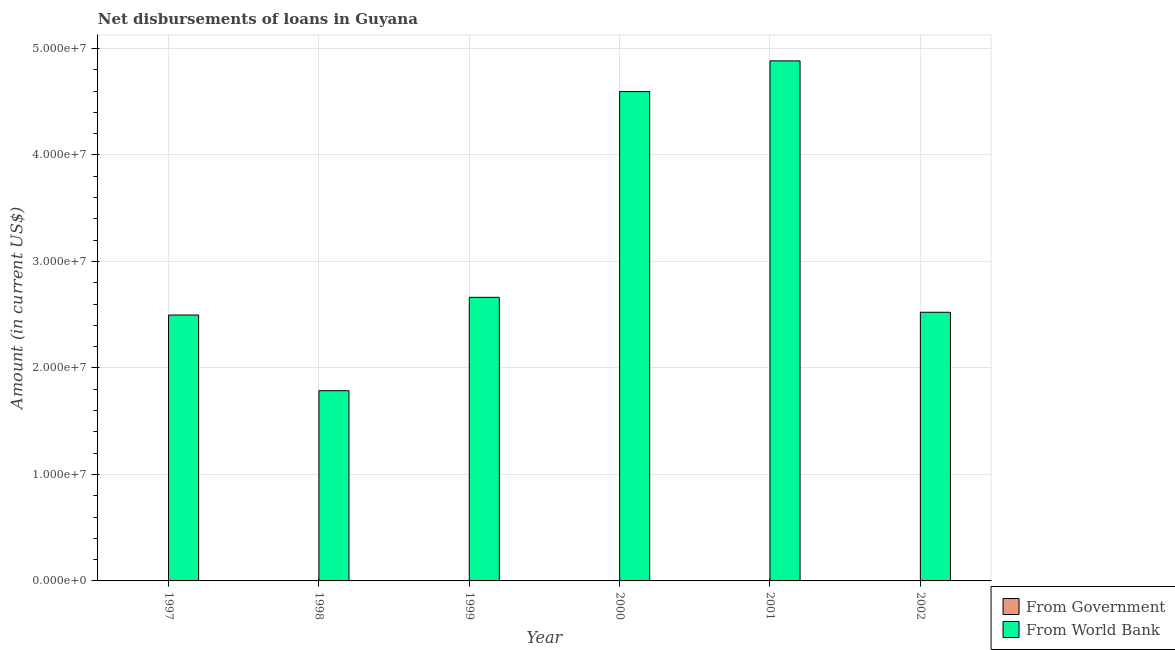How many different coloured bars are there?
Give a very brief answer. 1. Are the number of bars on each tick of the X-axis equal?
Provide a short and direct response. Yes. How many bars are there on the 3rd tick from the right?
Offer a very short reply. 1. What is the label of the 4th group of bars from the left?
Provide a short and direct response. 2000. In how many cases, is the number of bars for a given year not equal to the number of legend labels?
Offer a terse response. 6. Across all years, what is the maximum net disbursements of loan from world bank?
Make the answer very short. 4.88e+07. What is the total net disbursements of loan from world bank in the graph?
Provide a short and direct response. 1.89e+08. What is the difference between the net disbursements of loan from world bank in 1998 and that in 2000?
Your answer should be very brief. -2.81e+07. What is the ratio of the net disbursements of loan from world bank in 1997 to that in 1998?
Ensure brevity in your answer.  1.4. What is the difference between the highest and the second highest net disbursements of loan from world bank?
Provide a short and direct response. 2.88e+06. What is the difference between the highest and the lowest net disbursements of loan from world bank?
Your response must be concise. 3.10e+07. How many bars are there?
Give a very brief answer. 6. How many years are there in the graph?
Offer a terse response. 6. What is the difference between two consecutive major ticks on the Y-axis?
Make the answer very short. 1.00e+07. Are the values on the major ticks of Y-axis written in scientific E-notation?
Your response must be concise. Yes. Where does the legend appear in the graph?
Provide a succinct answer. Bottom right. What is the title of the graph?
Give a very brief answer. Net disbursements of loans in Guyana. What is the label or title of the X-axis?
Offer a very short reply. Year. What is the label or title of the Y-axis?
Your answer should be very brief. Amount (in current US$). What is the Amount (in current US$) of From World Bank in 1997?
Your answer should be very brief. 2.50e+07. What is the Amount (in current US$) in From World Bank in 1998?
Keep it short and to the point. 1.79e+07. What is the Amount (in current US$) of From World Bank in 1999?
Make the answer very short. 2.66e+07. What is the Amount (in current US$) in From Government in 2000?
Give a very brief answer. 0. What is the Amount (in current US$) in From World Bank in 2000?
Offer a very short reply. 4.60e+07. What is the Amount (in current US$) of From World Bank in 2001?
Ensure brevity in your answer.  4.88e+07. What is the Amount (in current US$) in From World Bank in 2002?
Offer a very short reply. 2.52e+07. Across all years, what is the maximum Amount (in current US$) in From World Bank?
Your response must be concise. 4.88e+07. Across all years, what is the minimum Amount (in current US$) in From World Bank?
Your answer should be compact. 1.79e+07. What is the total Amount (in current US$) in From Government in the graph?
Give a very brief answer. 0. What is the total Amount (in current US$) in From World Bank in the graph?
Your response must be concise. 1.89e+08. What is the difference between the Amount (in current US$) of From World Bank in 1997 and that in 1998?
Provide a succinct answer. 7.11e+06. What is the difference between the Amount (in current US$) of From World Bank in 1997 and that in 1999?
Your answer should be compact. -1.66e+06. What is the difference between the Amount (in current US$) in From World Bank in 1997 and that in 2000?
Offer a very short reply. -2.10e+07. What is the difference between the Amount (in current US$) of From World Bank in 1997 and that in 2001?
Keep it short and to the point. -2.39e+07. What is the difference between the Amount (in current US$) in From World Bank in 1997 and that in 2002?
Keep it short and to the point. -2.59e+05. What is the difference between the Amount (in current US$) of From World Bank in 1998 and that in 1999?
Your answer should be very brief. -8.77e+06. What is the difference between the Amount (in current US$) of From World Bank in 1998 and that in 2000?
Ensure brevity in your answer.  -2.81e+07. What is the difference between the Amount (in current US$) of From World Bank in 1998 and that in 2001?
Your answer should be very brief. -3.10e+07. What is the difference between the Amount (in current US$) of From World Bank in 1998 and that in 2002?
Ensure brevity in your answer.  -7.37e+06. What is the difference between the Amount (in current US$) in From World Bank in 1999 and that in 2000?
Your answer should be compact. -1.93e+07. What is the difference between the Amount (in current US$) of From World Bank in 1999 and that in 2001?
Your answer should be compact. -2.22e+07. What is the difference between the Amount (in current US$) in From World Bank in 1999 and that in 2002?
Your answer should be very brief. 1.40e+06. What is the difference between the Amount (in current US$) of From World Bank in 2000 and that in 2001?
Ensure brevity in your answer.  -2.88e+06. What is the difference between the Amount (in current US$) of From World Bank in 2000 and that in 2002?
Keep it short and to the point. 2.07e+07. What is the difference between the Amount (in current US$) in From World Bank in 2001 and that in 2002?
Ensure brevity in your answer.  2.36e+07. What is the average Amount (in current US$) in From World Bank per year?
Your answer should be compact. 3.16e+07. What is the ratio of the Amount (in current US$) of From World Bank in 1997 to that in 1998?
Offer a very short reply. 1.4. What is the ratio of the Amount (in current US$) in From World Bank in 1997 to that in 1999?
Your response must be concise. 0.94. What is the ratio of the Amount (in current US$) in From World Bank in 1997 to that in 2000?
Offer a terse response. 0.54. What is the ratio of the Amount (in current US$) in From World Bank in 1997 to that in 2001?
Give a very brief answer. 0.51. What is the ratio of the Amount (in current US$) in From World Bank in 1998 to that in 1999?
Offer a very short reply. 0.67. What is the ratio of the Amount (in current US$) of From World Bank in 1998 to that in 2000?
Your response must be concise. 0.39. What is the ratio of the Amount (in current US$) in From World Bank in 1998 to that in 2001?
Your answer should be compact. 0.37. What is the ratio of the Amount (in current US$) of From World Bank in 1998 to that in 2002?
Provide a short and direct response. 0.71. What is the ratio of the Amount (in current US$) in From World Bank in 1999 to that in 2000?
Ensure brevity in your answer.  0.58. What is the ratio of the Amount (in current US$) of From World Bank in 1999 to that in 2001?
Your answer should be compact. 0.55. What is the ratio of the Amount (in current US$) of From World Bank in 1999 to that in 2002?
Offer a very short reply. 1.06. What is the ratio of the Amount (in current US$) of From World Bank in 2000 to that in 2001?
Ensure brevity in your answer.  0.94. What is the ratio of the Amount (in current US$) of From World Bank in 2000 to that in 2002?
Make the answer very short. 1.82. What is the ratio of the Amount (in current US$) of From World Bank in 2001 to that in 2002?
Provide a succinct answer. 1.94. What is the difference between the highest and the second highest Amount (in current US$) in From World Bank?
Your response must be concise. 2.88e+06. What is the difference between the highest and the lowest Amount (in current US$) in From World Bank?
Keep it short and to the point. 3.10e+07. 